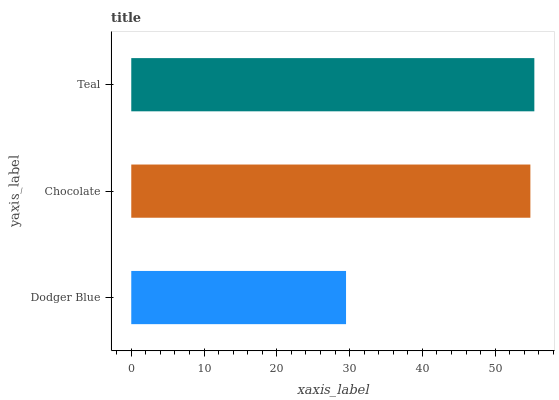Is Dodger Blue the minimum?
Answer yes or no. Yes. Is Teal the maximum?
Answer yes or no. Yes. Is Chocolate the minimum?
Answer yes or no. No. Is Chocolate the maximum?
Answer yes or no. No. Is Chocolate greater than Dodger Blue?
Answer yes or no. Yes. Is Dodger Blue less than Chocolate?
Answer yes or no. Yes. Is Dodger Blue greater than Chocolate?
Answer yes or no. No. Is Chocolate less than Dodger Blue?
Answer yes or no. No. Is Chocolate the high median?
Answer yes or no. Yes. Is Chocolate the low median?
Answer yes or no. Yes. Is Teal the high median?
Answer yes or no. No. Is Dodger Blue the low median?
Answer yes or no. No. 